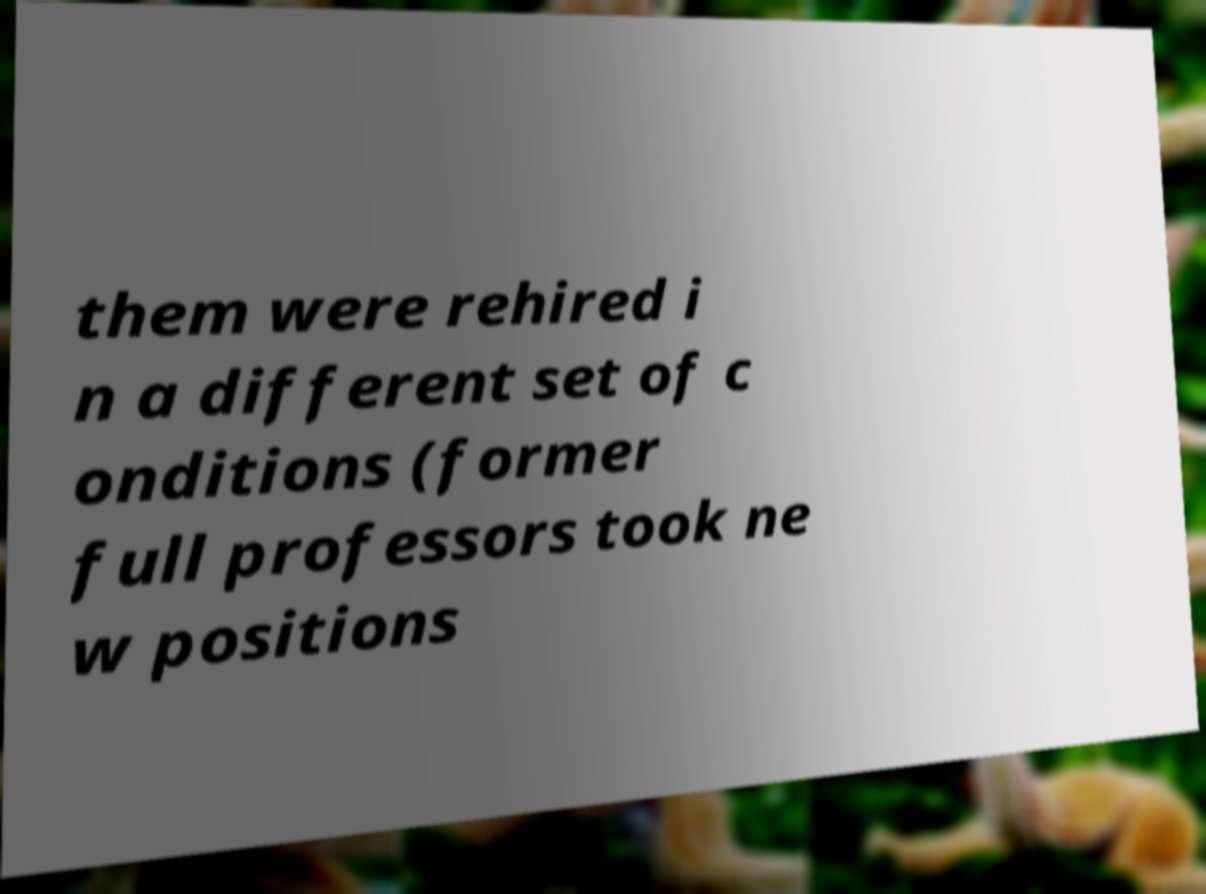Can you accurately transcribe the text from the provided image for me? them were rehired i n a different set of c onditions (former full professors took ne w positions 